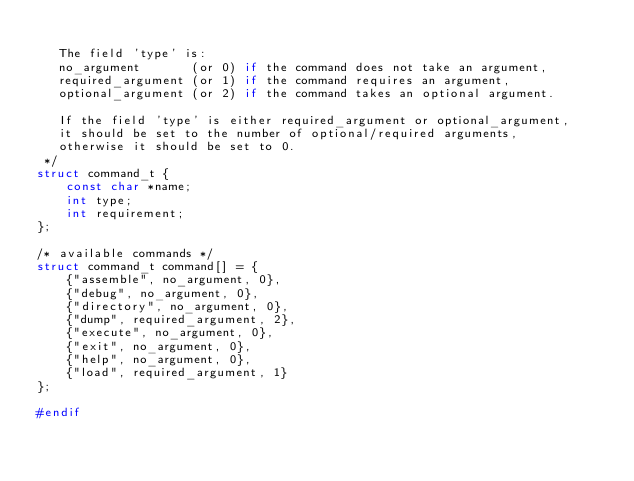Convert code to text. <code><loc_0><loc_0><loc_500><loc_500><_C_>
   The field 'type' is:
   no_argument       (or 0) if the command does not take an argument,
   required_argument (or 1) if the command requires an argument,
   optional_argument (or 2) if the command takes an optional argument.

   If the field 'type' is either required_argument or optional_argument,
   it should be set to the number of optional/required arguments,
   otherwise it should be set to 0.
 */
struct command_t {
	const char *name;
	int type;
	int requirement;
};

/* available commands */
struct command_t command[] = {
	{"assemble", no_argument, 0},
	{"debug", no_argument, 0},
	{"directory", no_argument, 0},
	{"dump", required_argument, 2},
	{"execute", no_argument, 0},
	{"exit", no_argument, 0},
	{"help", no_argument, 0},
	{"load", required_argument, 1}
};

#endif
</code> 